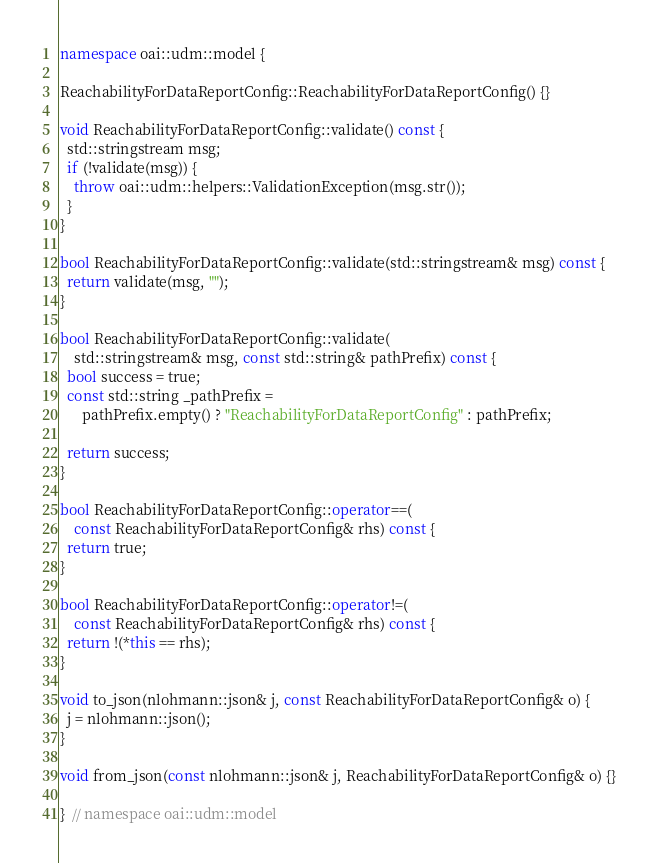<code> <loc_0><loc_0><loc_500><loc_500><_C++_>namespace oai::udm::model {

ReachabilityForDataReportConfig::ReachabilityForDataReportConfig() {}

void ReachabilityForDataReportConfig::validate() const {
  std::stringstream msg;
  if (!validate(msg)) {
    throw oai::udm::helpers::ValidationException(msg.str());
  }
}

bool ReachabilityForDataReportConfig::validate(std::stringstream& msg) const {
  return validate(msg, "");
}

bool ReachabilityForDataReportConfig::validate(
    std::stringstream& msg, const std::string& pathPrefix) const {
  bool success = true;
  const std::string _pathPrefix =
      pathPrefix.empty() ? "ReachabilityForDataReportConfig" : pathPrefix;

  return success;
}

bool ReachabilityForDataReportConfig::operator==(
    const ReachabilityForDataReportConfig& rhs) const {
  return true;
}

bool ReachabilityForDataReportConfig::operator!=(
    const ReachabilityForDataReportConfig& rhs) const {
  return !(*this == rhs);
}

void to_json(nlohmann::json& j, const ReachabilityForDataReportConfig& o) {
  j = nlohmann::json();
}

void from_json(const nlohmann::json& j, ReachabilityForDataReportConfig& o) {}

}  // namespace oai::udm::model
</code> 